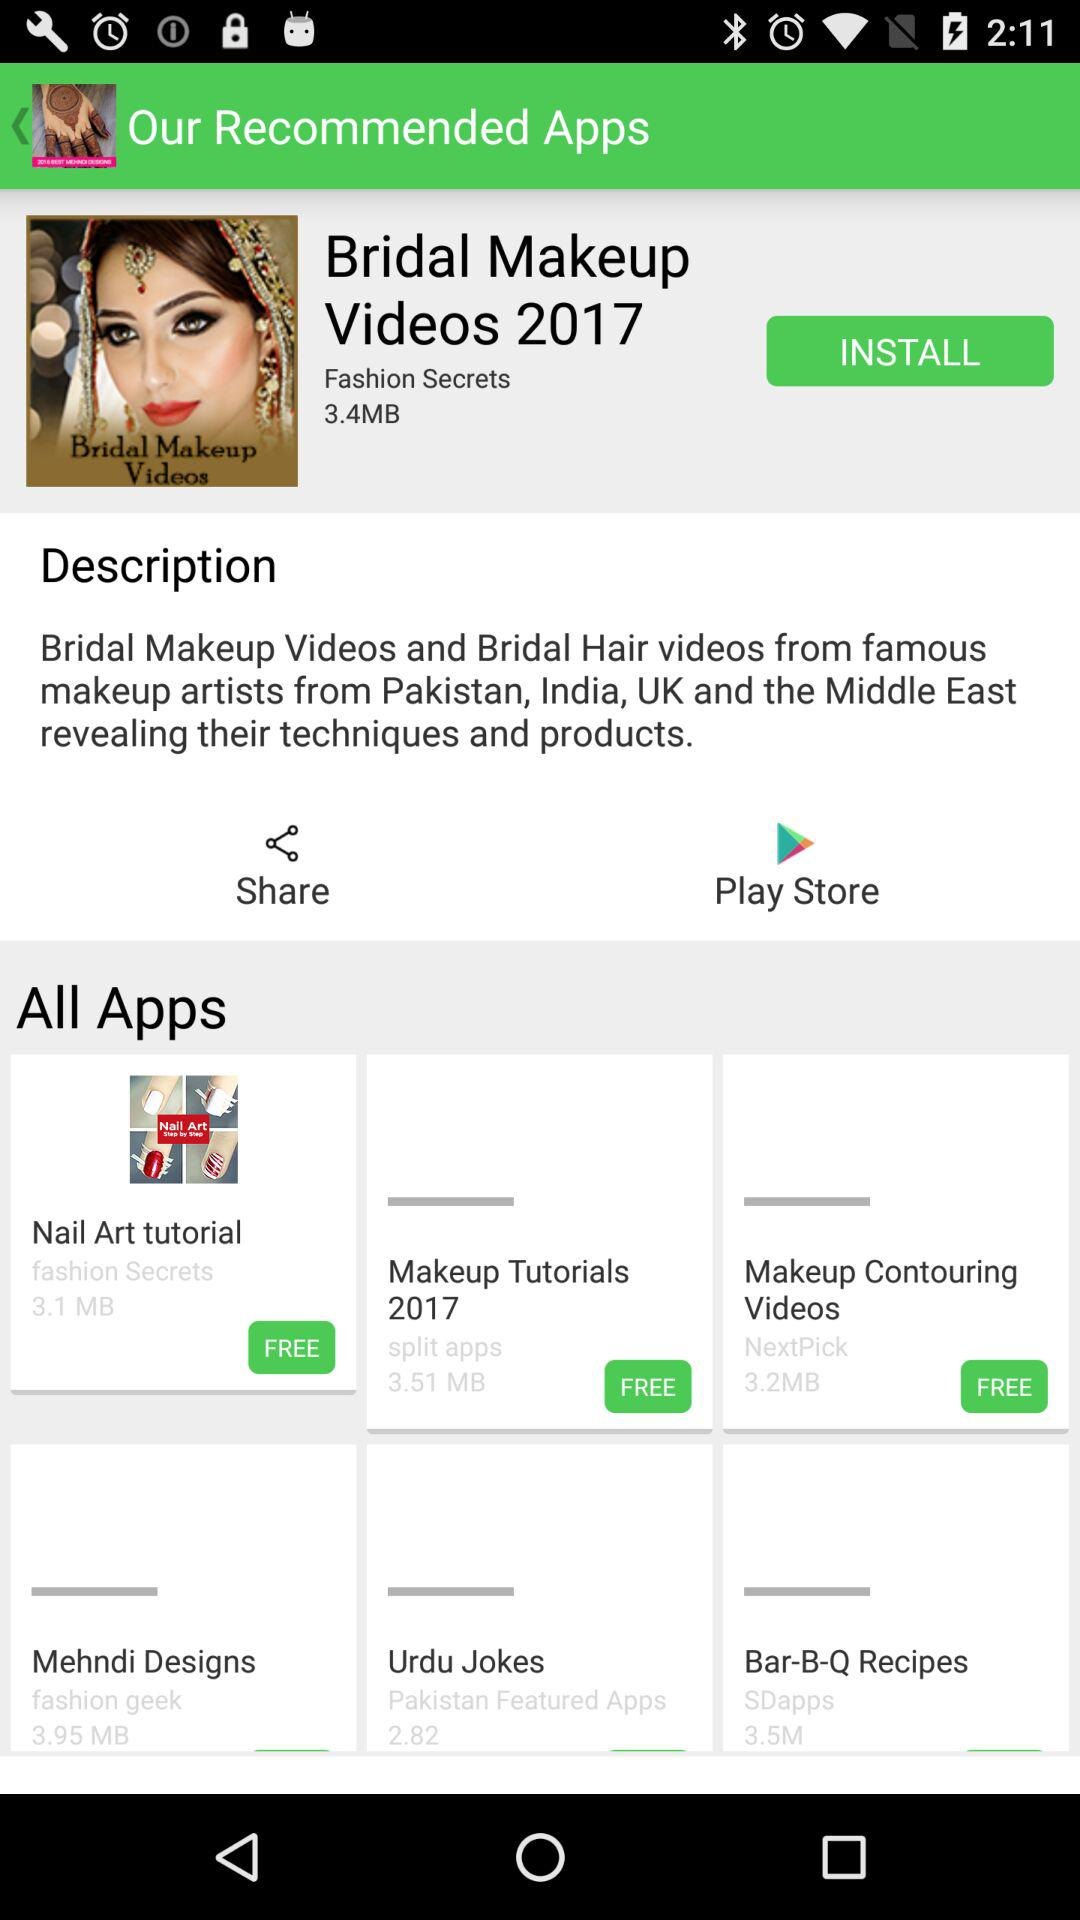What is the year given for bridal makeup videos? The given year is 2017. 